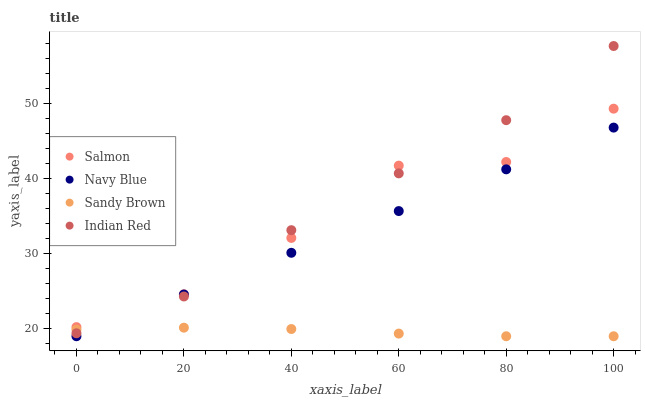Does Sandy Brown have the minimum area under the curve?
Answer yes or no. Yes. Does Indian Red have the maximum area under the curve?
Answer yes or no. Yes. Does Salmon have the minimum area under the curve?
Answer yes or no. No. Does Salmon have the maximum area under the curve?
Answer yes or no. No. Is Navy Blue the smoothest?
Answer yes or no. Yes. Is Salmon the roughest?
Answer yes or no. Yes. Is Indian Red the smoothest?
Answer yes or no. No. Is Indian Red the roughest?
Answer yes or no. No. Does Navy Blue have the lowest value?
Answer yes or no. Yes. Does Indian Red have the lowest value?
Answer yes or no. No. Does Indian Red have the highest value?
Answer yes or no. Yes. Does Salmon have the highest value?
Answer yes or no. No. Is Navy Blue less than Salmon?
Answer yes or no. Yes. Is Salmon greater than Sandy Brown?
Answer yes or no. Yes. Does Sandy Brown intersect Indian Red?
Answer yes or no. Yes. Is Sandy Brown less than Indian Red?
Answer yes or no. No. Is Sandy Brown greater than Indian Red?
Answer yes or no. No. Does Navy Blue intersect Salmon?
Answer yes or no. No. 